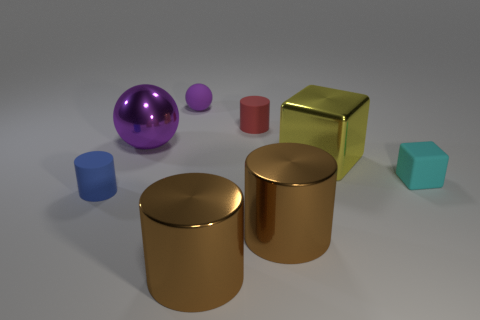What is the size of the thing that is the same color as the rubber sphere?
Ensure brevity in your answer.  Large. What color is the large sphere?
Offer a terse response. Purple. There is a matte cylinder in front of the small cyan matte thing; is its size the same as the block behind the cyan thing?
Your answer should be very brief. No. Is the number of yellow things less than the number of big metallic things?
Give a very brief answer. Yes. There is a small red cylinder; how many small cylinders are on the left side of it?
Your answer should be very brief. 1. What material is the tiny red cylinder?
Your answer should be very brief. Rubber. Does the big ball have the same color as the small ball?
Make the answer very short. Yes. Are there fewer red cylinders that are right of the tiny purple matte object than spheres?
Your response must be concise. Yes. What color is the small cylinder behind the yellow cube?
Provide a short and direct response. Red. The small blue thing is what shape?
Keep it short and to the point. Cylinder. 